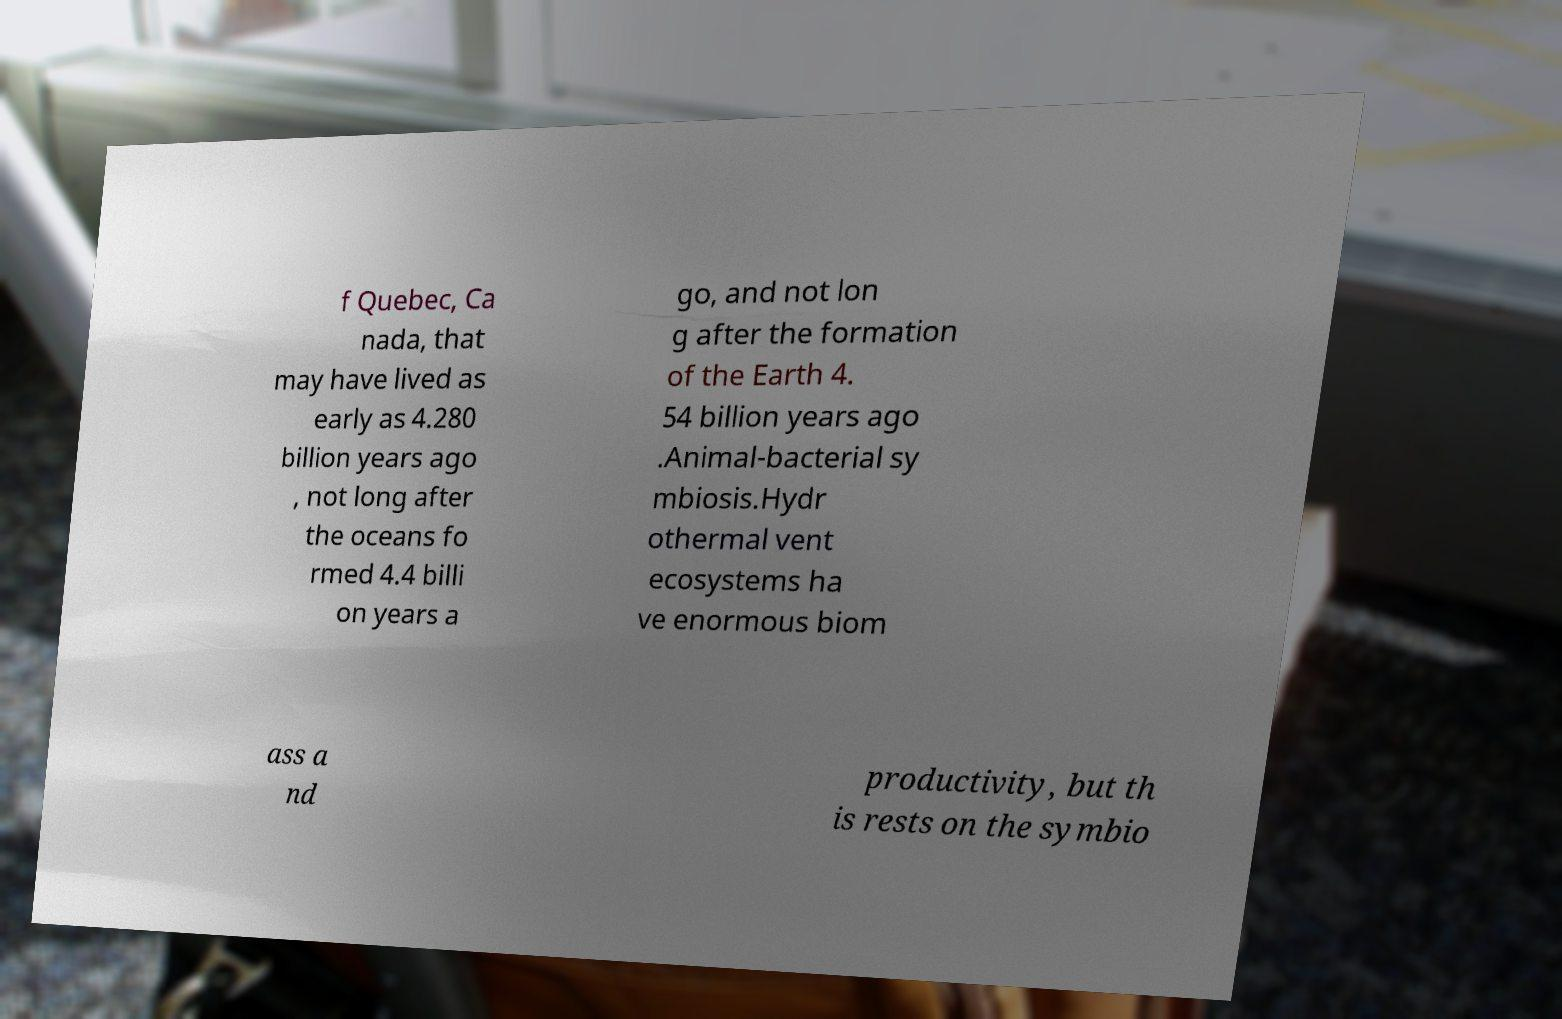I need the written content from this picture converted into text. Can you do that? f Quebec, Ca nada, that may have lived as early as 4.280 billion years ago , not long after the oceans fo rmed 4.4 billi on years a go, and not lon g after the formation of the Earth 4. 54 billion years ago .Animal-bacterial sy mbiosis.Hydr othermal vent ecosystems ha ve enormous biom ass a nd productivity, but th is rests on the symbio 